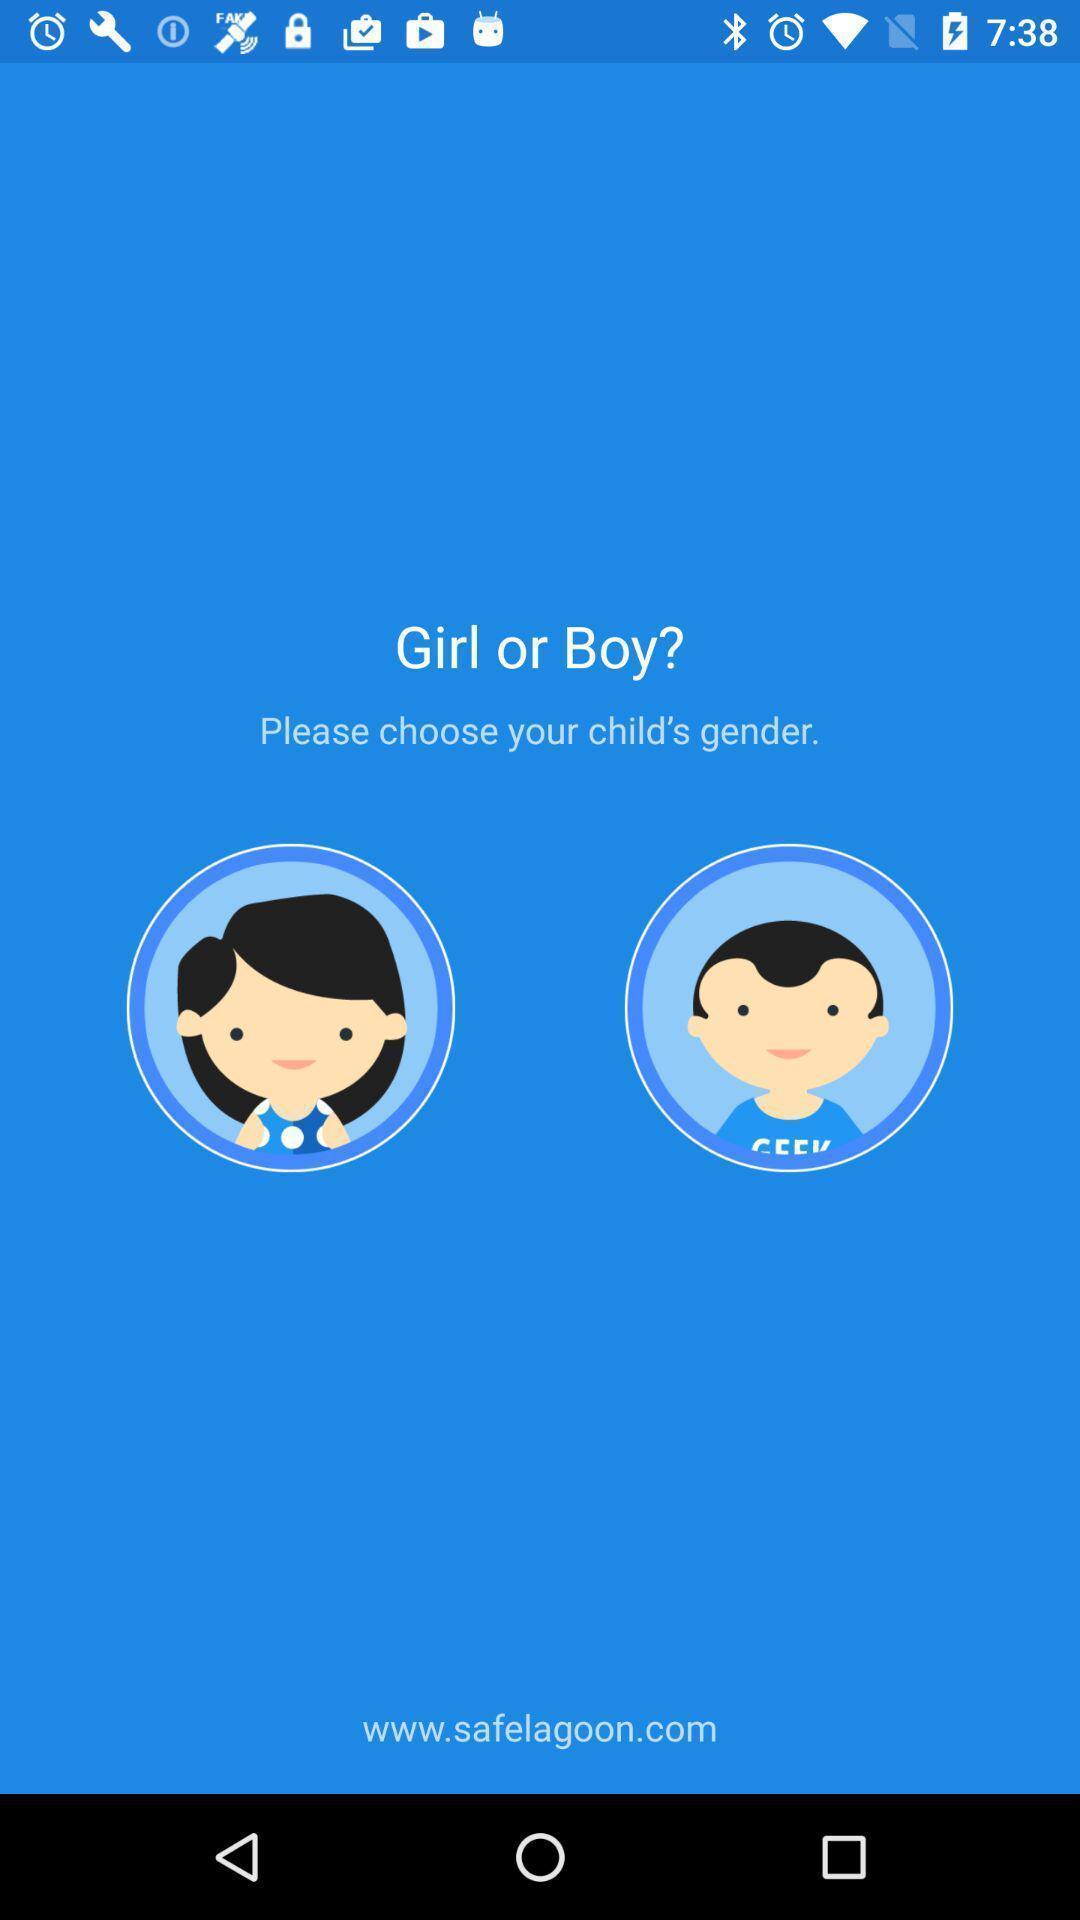Explain what's happening in this screen capture. Screen showing girl or boy options to select. 